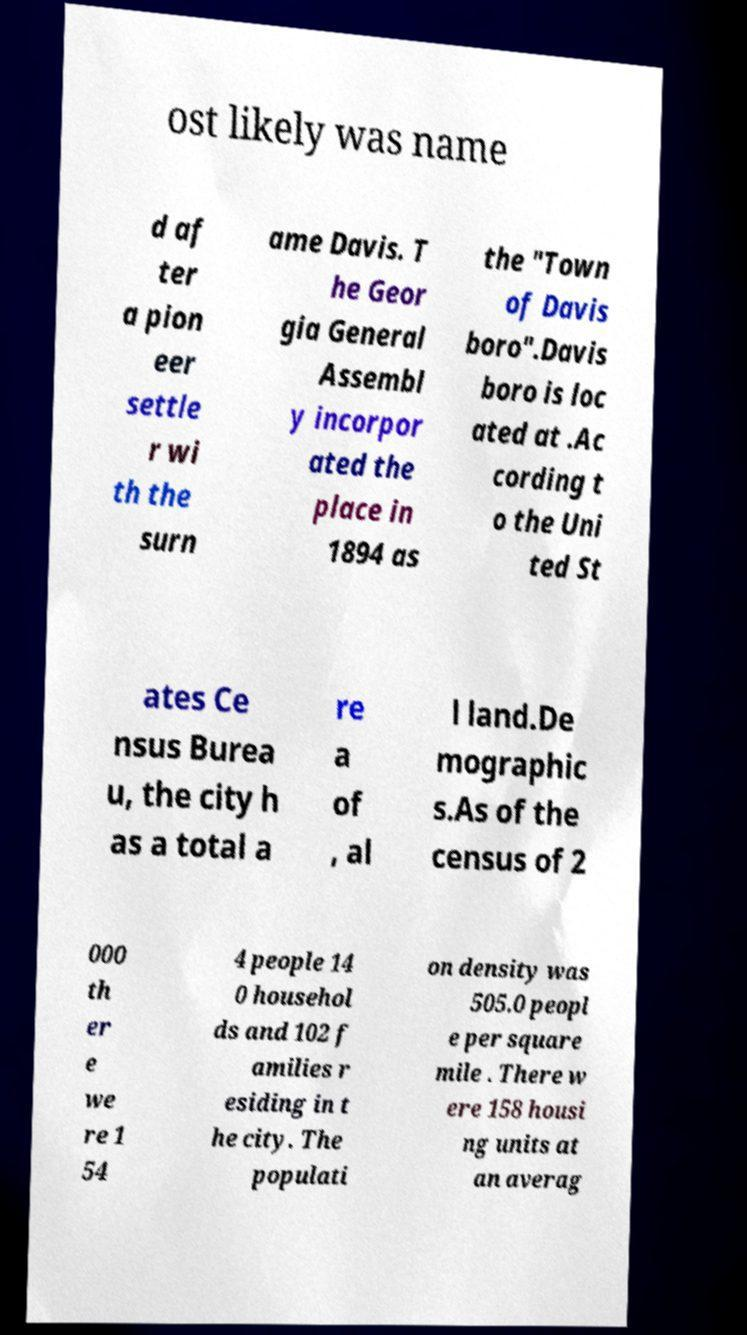Please read and relay the text visible in this image. What does it say? ost likely was name d af ter a pion eer settle r wi th the surn ame Davis. T he Geor gia General Assembl y incorpor ated the place in 1894 as the "Town of Davis boro".Davis boro is loc ated at .Ac cording t o the Uni ted St ates Ce nsus Burea u, the city h as a total a re a of , al l land.De mographic s.As of the census of 2 000 th er e we re 1 54 4 people 14 0 househol ds and 102 f amilies r esiding in t he city. The populati on density was 505.0 peopl e per square mile . There w ere 158 housi ng units at an averag 